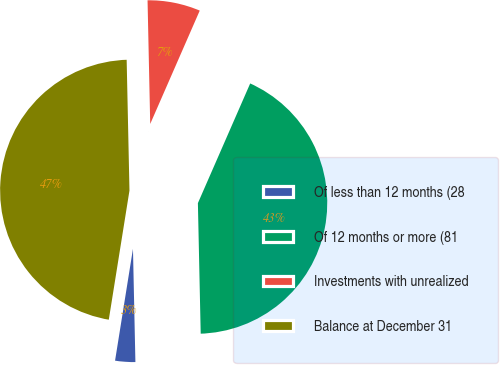Convert chart to OTSL. <chart><loc_0><loc_0><loc_500><loc_500><pie_chart><fcel>Of less than 12 months (28<fcel>Of 12 months or more (81<fcel>Investments with unrealized<fcel>Balance at December 31<nl><fcel>2.87%<fcel>43.1%<fcel>6.9%<fcel>47.13%<nl></chart> 